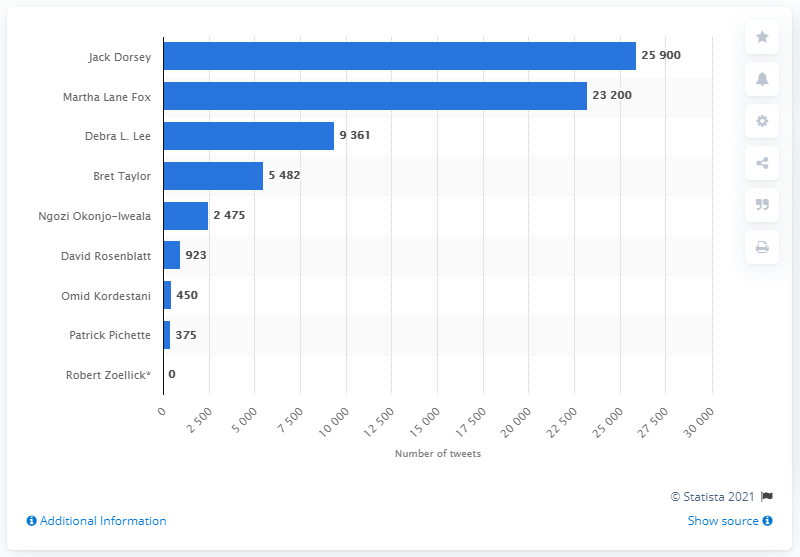List a handful of essential elements in this visual. Jack Dorsey was the founder of Twitter in July of 2019. Martha Lane Fox was the second most prolific Twitter user. 